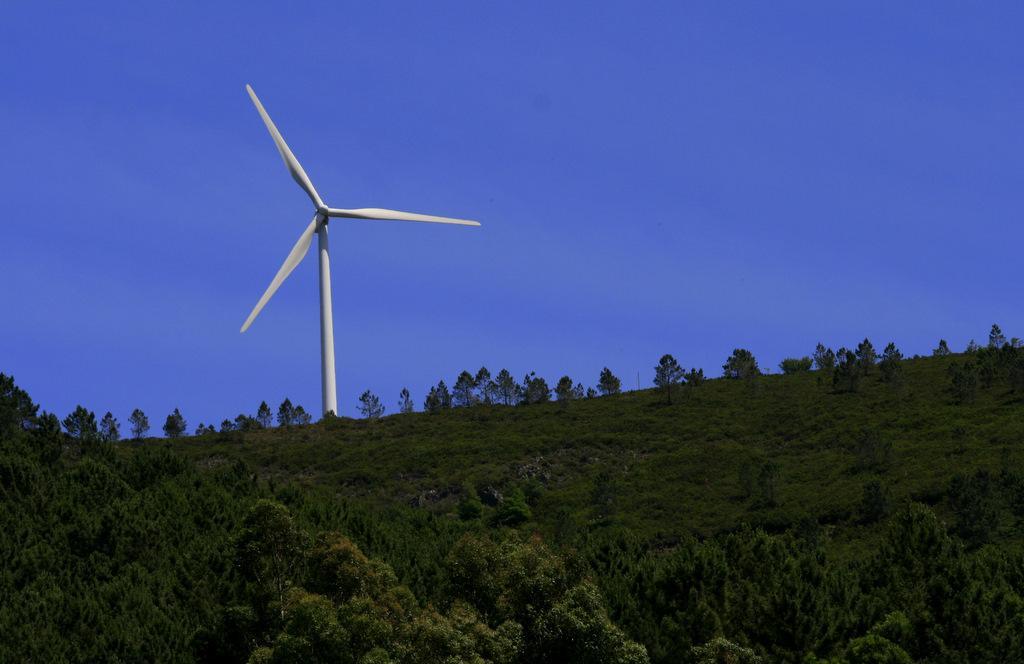Describe this image in one or two sentences. In the picture we can see the hill slope covered with plants and trees and on the top of the hill we can see a windmill and behind it we can see the sky. 